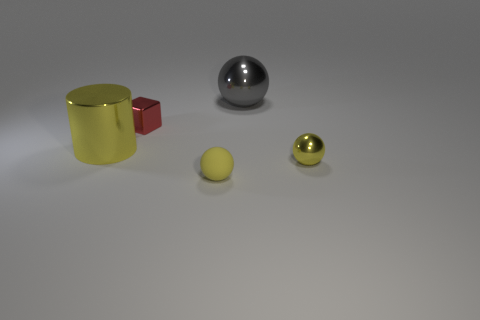What size is the cylinder that is the same color as the matte thing?
Your answer should be compact. Large. The yellow ball that is made of the same material as the gray thing is what size?
Your answer should be compact. Small. There is another metallic thing that is the same shape as the big gray shiny thing; what size is it?
Ensure brevity in your answer.  Small. There is another small object that is the same color as the small rubber thing; what is its shape?
Your response must be concise. Sphere. There is a tiny yellow object that is left of the tiny yellow metal ball; what number of large cylinders are in front of it?
Provide a succinct answer. 0. Is the size of the yellow shiny thing on the left side of the gray sphere the same as the gray metallic object?
Give a very brief answer. Yes. What number of other red shiny things are the same shape as the tiny red shiny object?
Offer a terse response. 0. What is the shape of the big yellow object?
Your answer should be very brief. Cylinder. Are there an equal number of things to the left of the tiny yellow rubber ball and small shiny objects?
Make the answer very short. Yes. Does the object behind the red thing have the same material as the small red object?
Make the answer very short. Yes. 